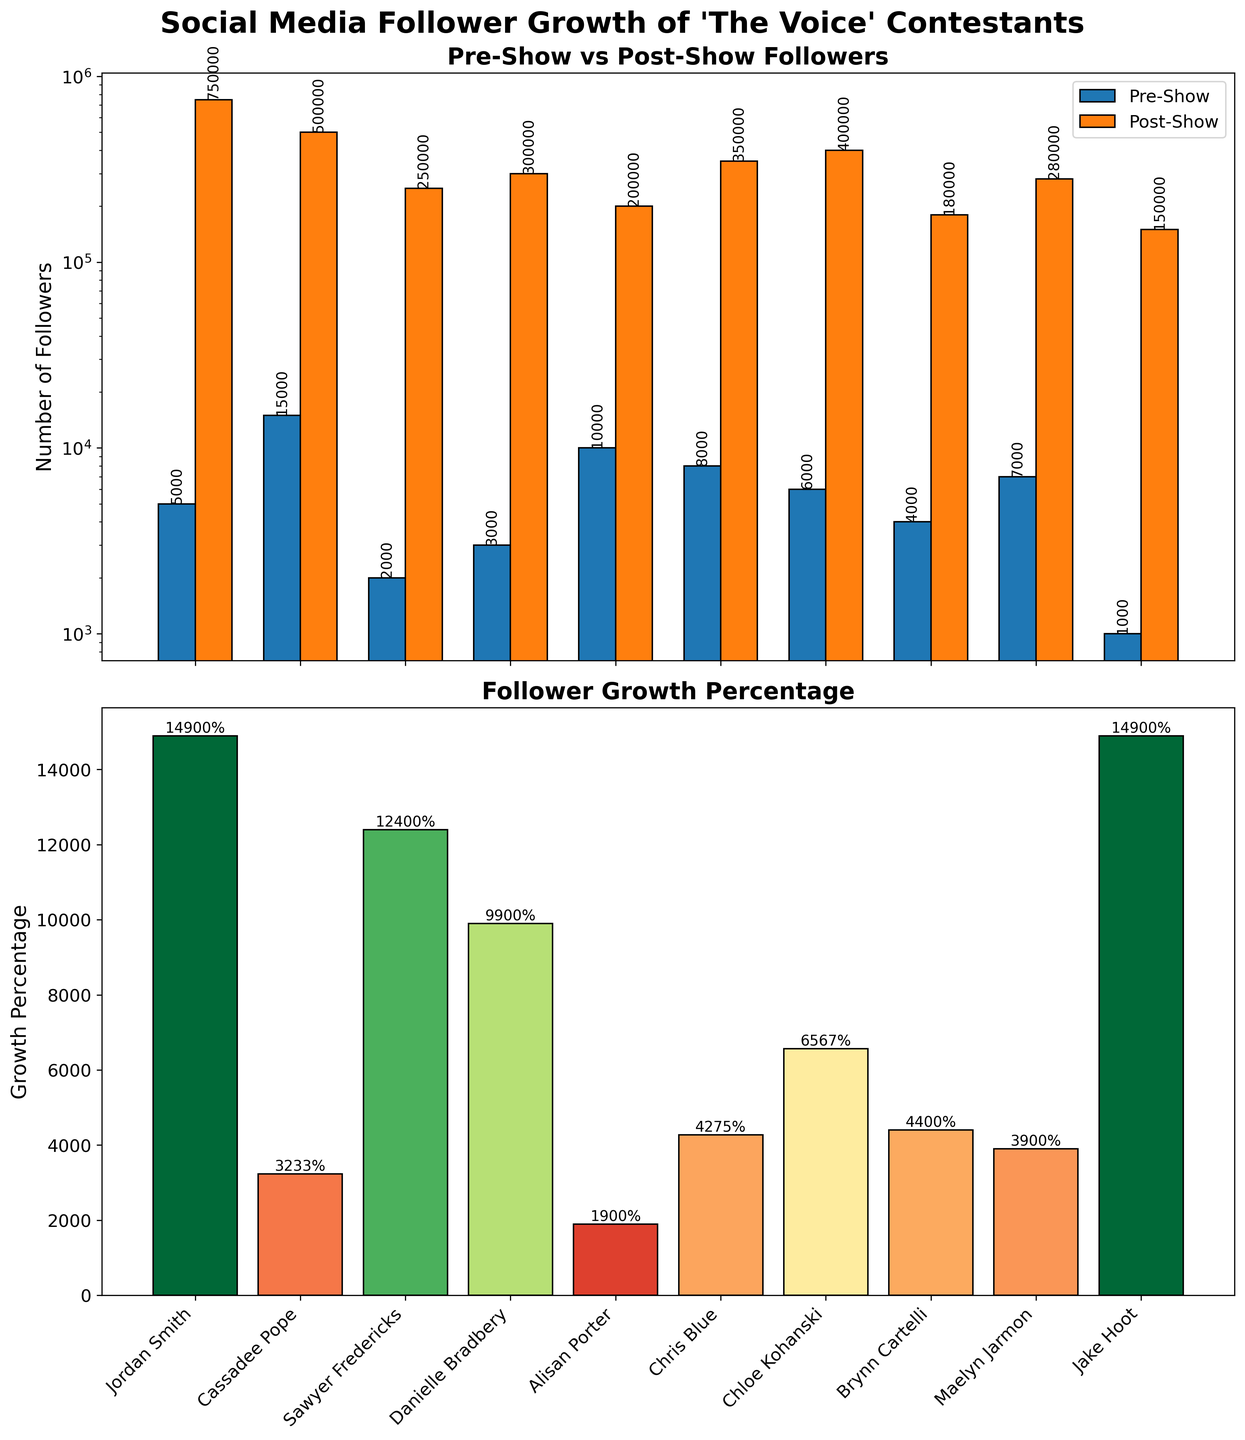What is the title of the figure? The title is located at the top of the figure. It reads "Social Media Follower Growth of 'The Voice' Contestants".
Answer: Social Media Follower Growth of 'The Voice' Contestants How many contestants are shown in the figure? The x-axis shows the names of all the contestants. Counting these names reveals there are 10 contestants.
Answer: 10 What is the color used for the Pre-Show followers' bar? The color legend in the figure indicates that the Pre-Show follower bars are in blue.
Answer: Blue Which contestant has the highest number of Post-Show followers? By comparing the heights of the Post-Show bars, Jordan Smith has the tallest bar, indicating the highest number of followers.
Answer: Jordan Smith For which contestant is the difference between Pre-Show and Post-Show followers the greatest? Jordan Smith shows the largest numerical difference by observing the difference in bar heights between Pre-Show and Post-Show columns.
Answer: Jordan Smith What is the growth percentage of Maelyn Jarmon? In the second subplot, find Maelyn Jarmon's bar. The value at the top of this bar is 3900%, representing her growth percentage.
Answer: 3900% Which contestant has the lowest Pre-Show follower count? By comparing the heights of the Pre-Show bars, Jake Hoot has the smallest bar, indicating the lowest follower count.
Answer: Jake Hoot What is the general trend observed between Pre-Show and Post-Show followers? All Post-Show bars are taller than their corresponding Pre-Show bars, suggesting an increase in followers for all contestants.
Answer: Increase in followers How does Danielle Bradbery's follower growth compare to Chloe Kohanski's? Looking at the second subplot, find and compare the bars for Danielle Bradbery and Chloe Kohanski. Danielle Bradbery has taller growth value.
Answer: Danielle Bradbery > Chloe Kohanski Which contestant has the lowest growth percentage? In the second subplot, the shortest bar belongs to Alisan Porter, indicating the lowest growth percentage.
Answer: Alisan Porter 